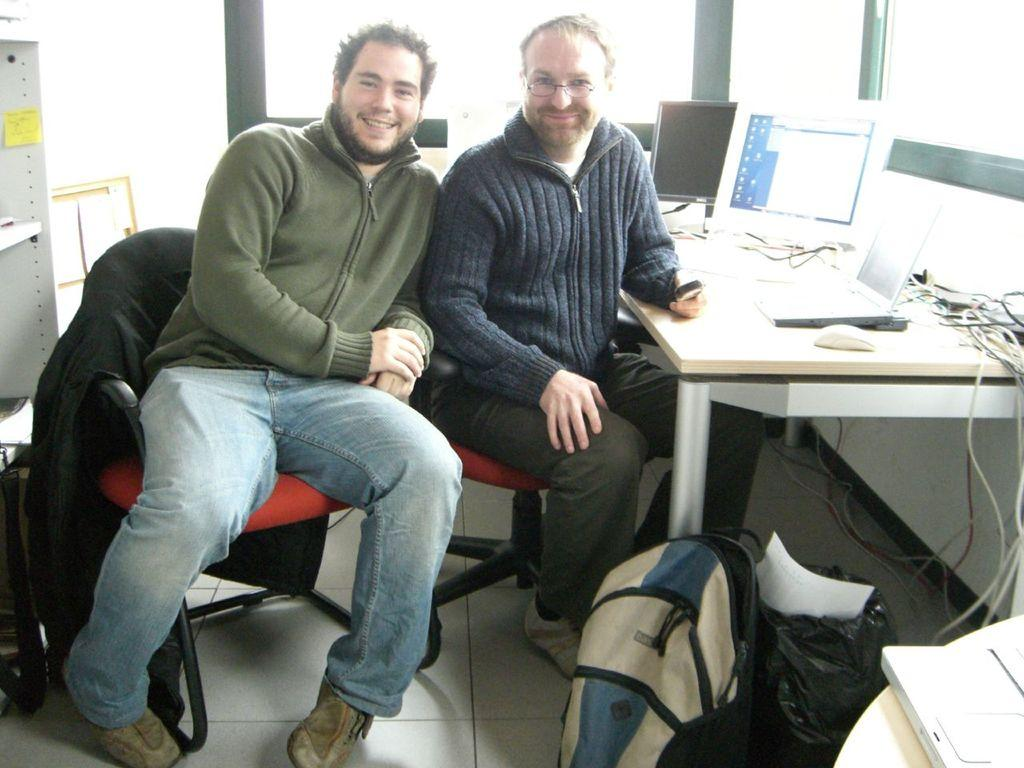How many people are in the image? There are two men in the image. What are the men doing in the image? The men are sitting in chairs and posing at the camera. What expression do the men have in the image? The men are smiling in the image. What type of leg is being used as a table in the image? There is no table or leg present in the image; it features two men sitting in chairs and posing at the camera. 